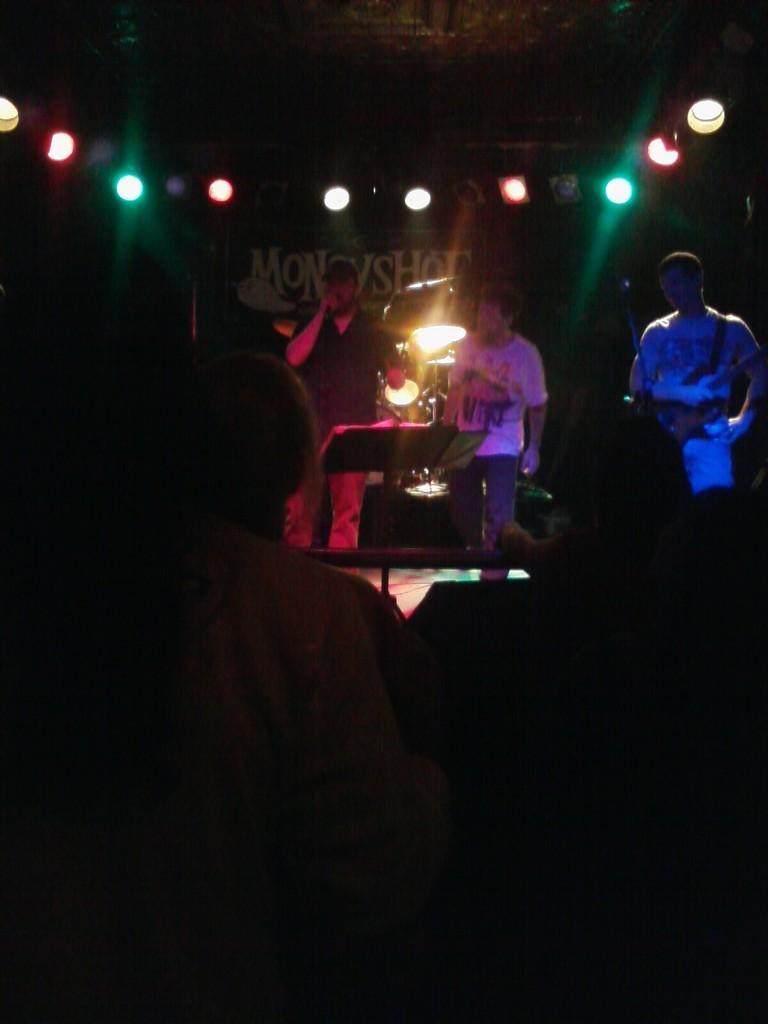Could you give a brief overview of what you see in this image? In this picture I can see few people standing in front and I see that it is dark and I can see the lights in the background and I see 3 men, who are standing and I see few things. 